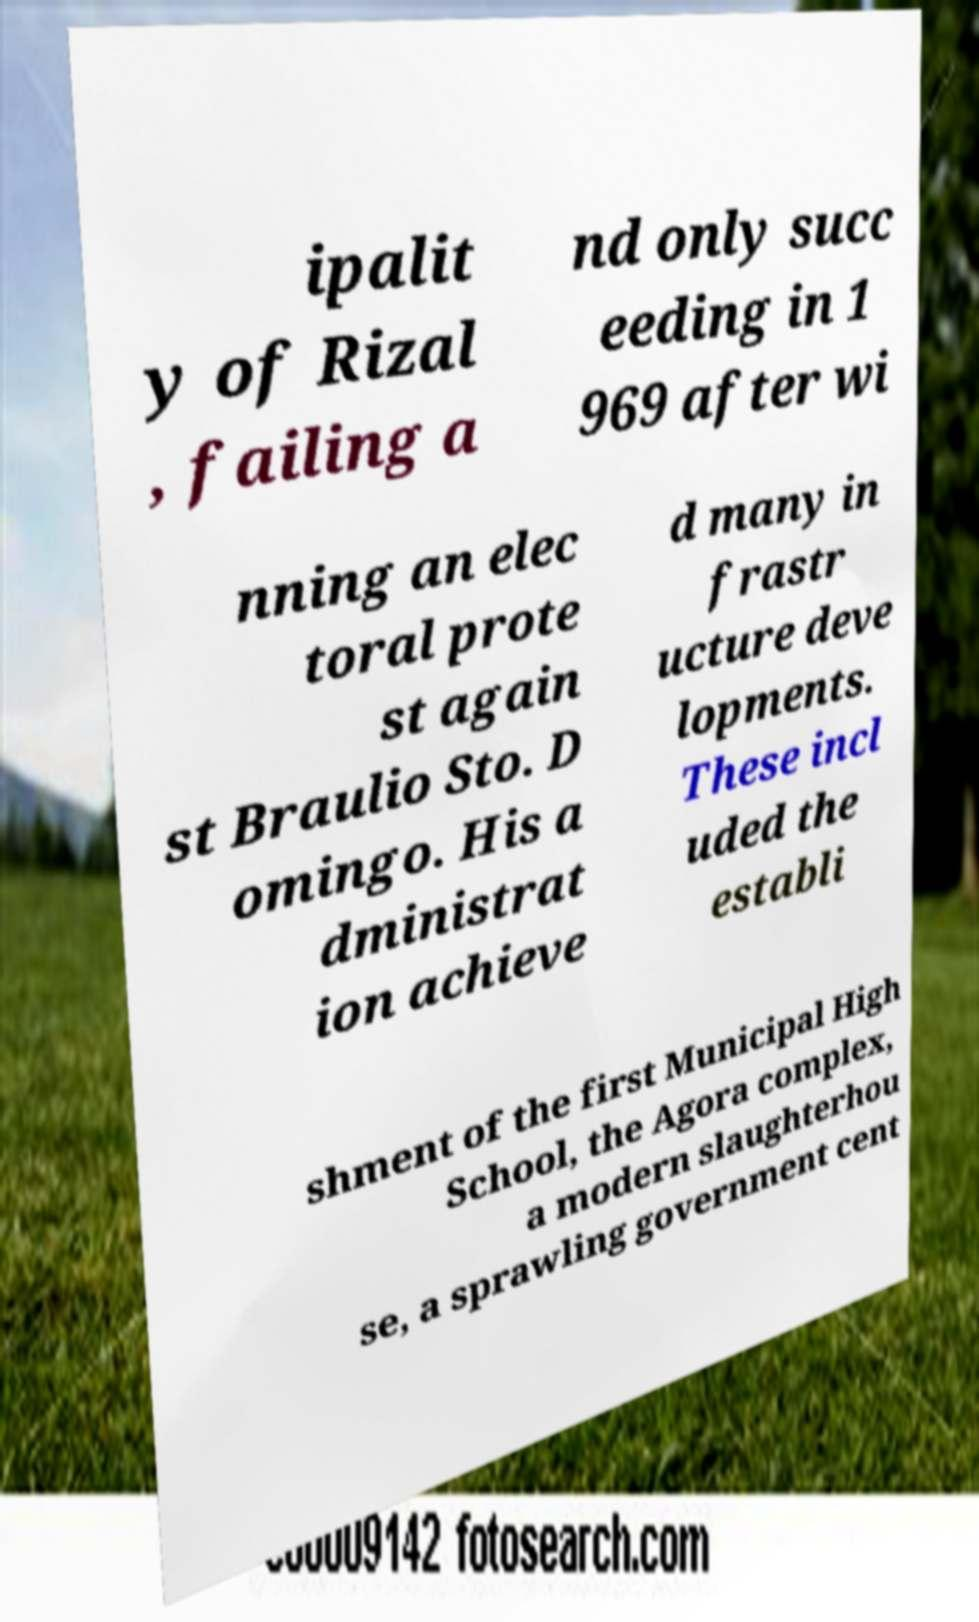What messages or text are displayed in this image? I need them in a readable, typed format. ipalit y of Rizal , failing a nd only succ eeding in 1 969 after wi nning an elec toral prote st again st Braulio Sto. D omingo. His a dministrat ion achieve d many in frastr ucture deve lopments. These incl uded the establi shment of the first Municipal High School, the Agora complex, a modern slaughterhou se, a sprawling government cent 